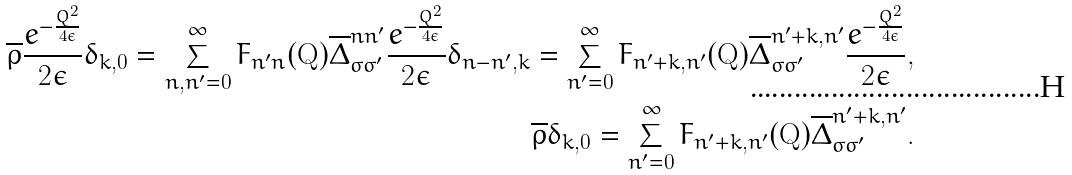Convert formula to latex. <formula><loc_0><loc_0><loc_500><loc_500>\overline { \rho } \frac { e ^ { - \frac { Q ^ { 2 } } { 4 \epsilon } } } { 2 \epsilon } \delta _ { k , 0 } = \sum _ { n , n ^ { \prime } = 0 } ^ { \infty } F _ { n ^ { \prime } n } ( \mathbf Q ) \overline { \Delta } ^ { n n ^ { \prime } } _ { \sigma \sigma ^ { \prime } } \frac { e ^ { - \frac { Q ^ { 2 } } { 4 \epsilon } } } { 2 \epsilon } \delta _ { n - n ^ { \prime } , k } = \sum _ { n ^ { \prime } = 0 } ^ { \infty } F _ { n ^ { \prime } + k , n ^ { \prime } } ( \mathbf Q ) \overline { \Delta } ^ { n ^ { \prime } + k , n ^ { \prime } } _ { \sigma \sigma ^ { \prime } } \frac { e ^ { - \frac { Q ^ { 2 } } { 4 \epsilon } } } { 2 \epsilon } , \\ \overline { \rho } \delta _ { k , 0 } = \sum _ { n ^ { \prime } = 0 } ^ { \infty } F _ { n ^ { \prime } + k , n ^ { \prime } } ( \mathbf Q ) \overline { \Delta } ^ { n ^ { \prime } + k , n ^ { \prime } } _ { \sigma \sigma ^ { \prime } } .</formula> 